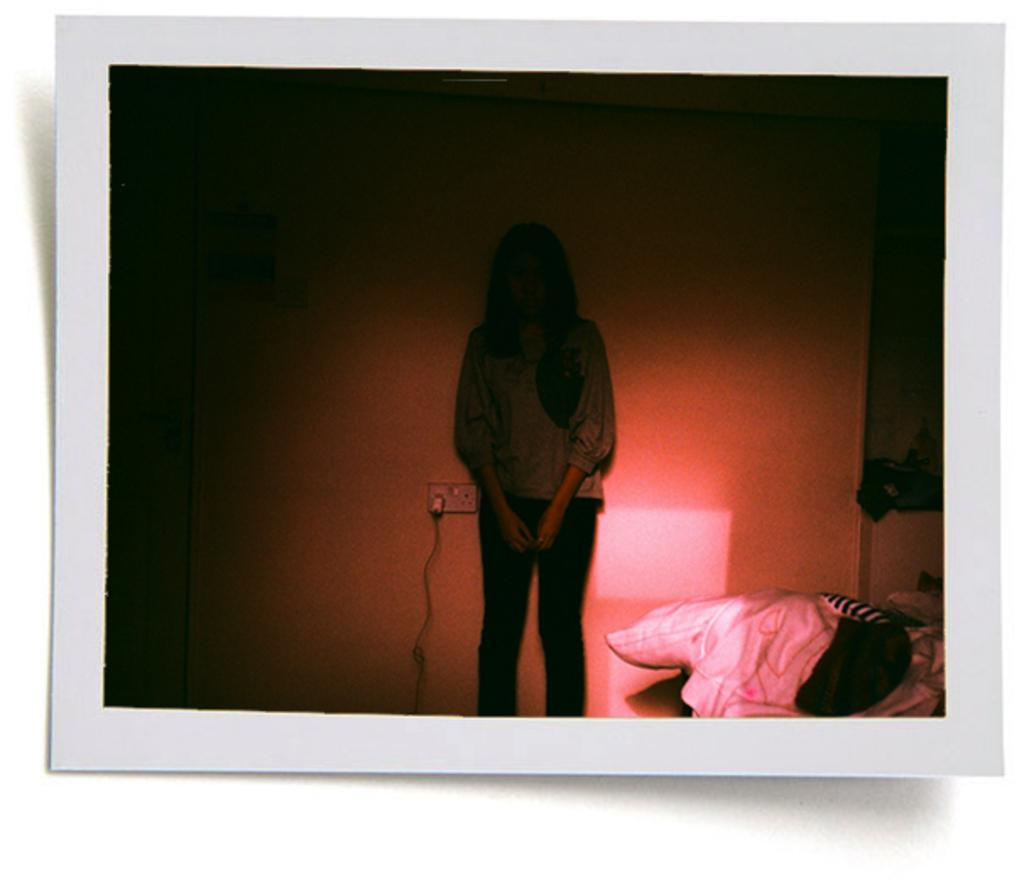What is the main subject in the image? There is a person standing in the image. What can be seen near the person? There is a lamp in the image. What is the background of the image? There is a wall in the image. What is connected to the wall? There is a cable and a socket in the image. What objects are located in the bottom right corner of the image? There are objects in the bottom right corner of the image. What type of education is the person pursuing in the image? There is no indication of the person's education in the image. How many knees can be seen in the image? There is only one person in the image, and it is not possible to see their knees. 